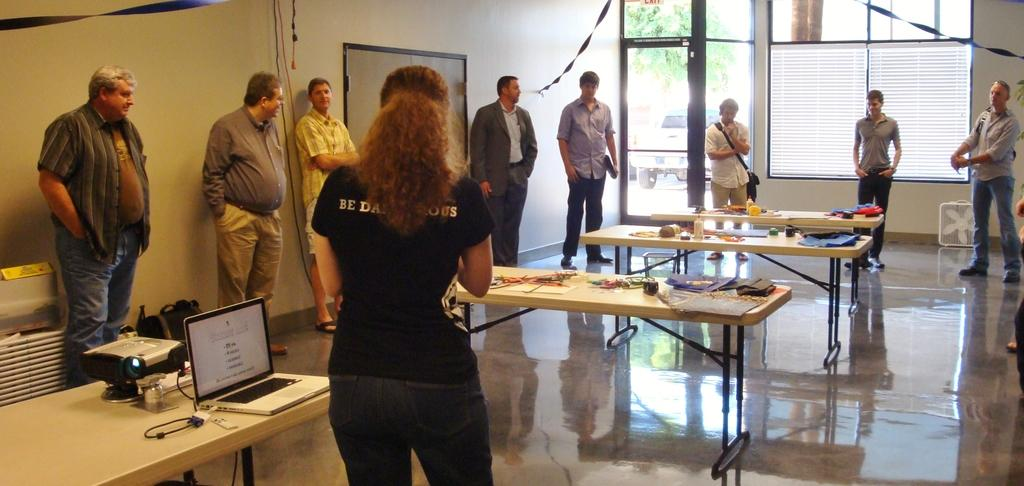What can be seen in the image involving people? There are people standing in the image. What objects are on the table in the image? There are bottles, a cloth, a laptop, and a projector on the table. What might the people be using the laptop for? It is not clear from the image what the people are using the laptop for, but it could be for work, entertainment, or communication. What is the purpose of the projector in the image? The projector might be used for displaying presentations, videos, or images during a meeting or event. What type of picture is hanging on the wall in the image? There is no mention of a picture hanging on the wall in the image; only the people, bottles, cloth, laptop, and projector are described. 